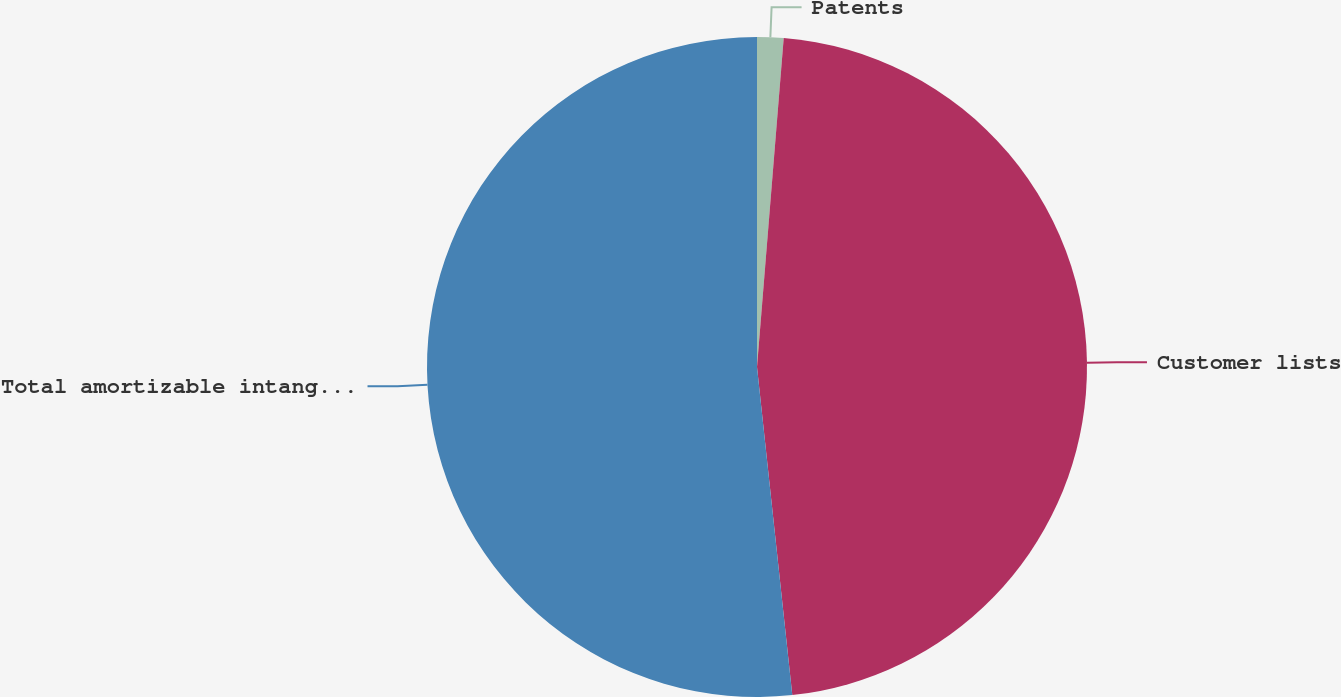<chart> <loc_0><loc_0><loc_500><loc_500><pie_chart><fcel>Patents<fcel>Customer lists<fcel>Total amortizable intangible<nl><fcel>1.29%<fcel>47.01%<fcel>51.71%<nl></chart> 